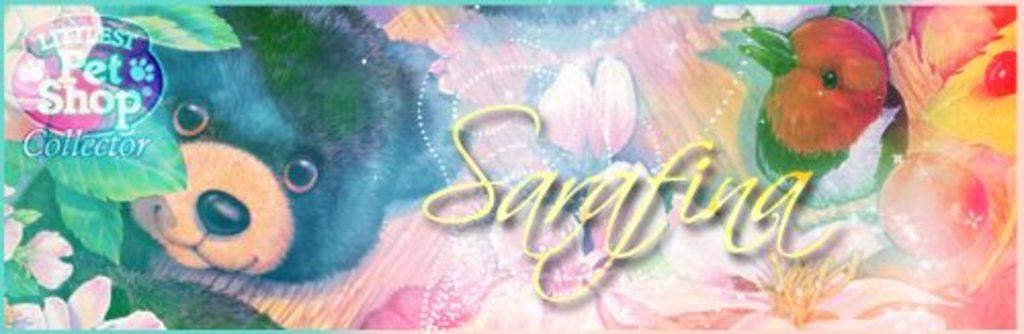In one or two sentences, can you explain what this image depicts? This image looks like a edited photo, on which there is a text, bird, animal, flowers, leaves, logo. 